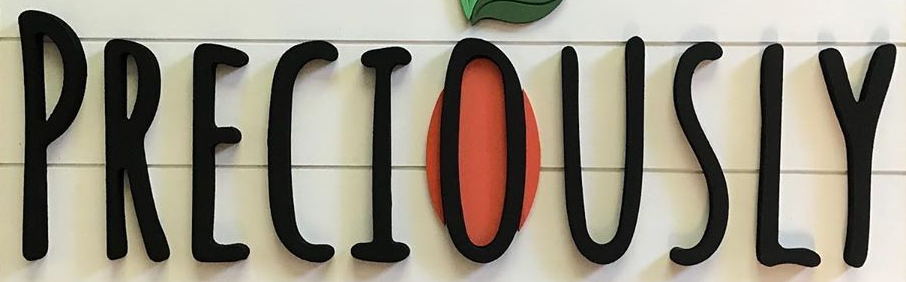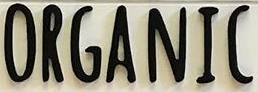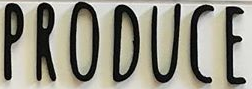Read the text from these images in sequence, separated by a semicolon. PRECIOUSLY; ORGANIC; PRODUCE 